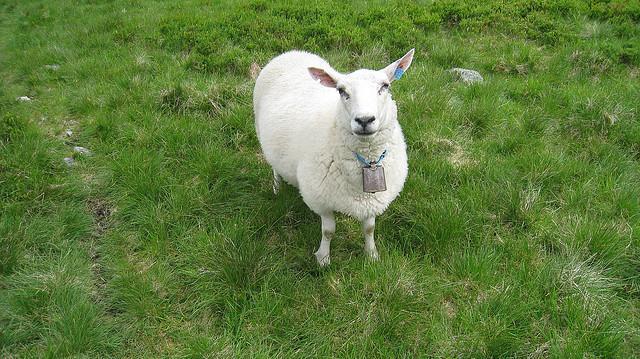How many total ears are there in this picture?
Give a very brief answer. 2. 